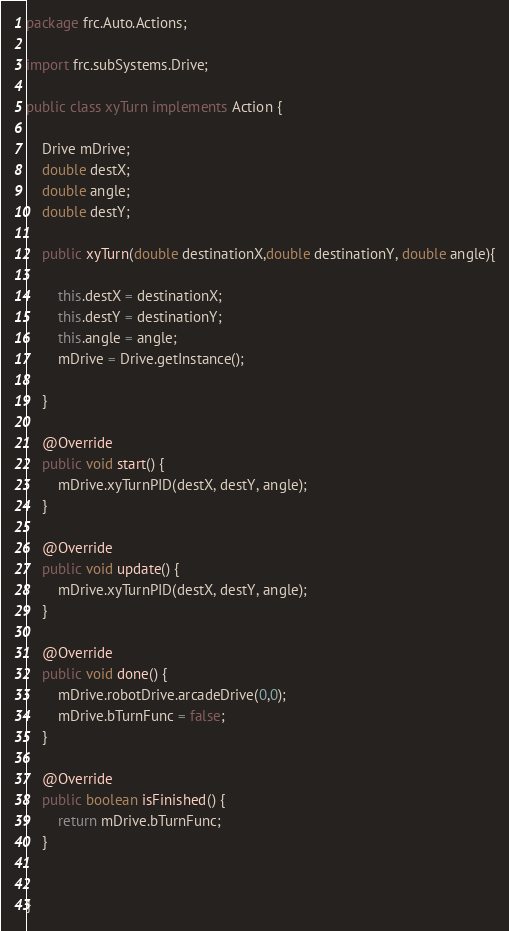<code> <loc_0><loc_0><loc_500><loc_500><_Java_>package frc.Auto.Actions;

import frc.subSystems.Drive;

public class xyTurn implements Action {

    Drive mDrive;
    double destX;
    double angle;
    double destY;

    public xyTurn(double destinationX,double destinationY, double angle){

        this.destX = destinationX;
        this.destY = destinationY;
        this.angle = angle;
        mDrive = Drive.getInstance();

    }

    @Override
    public void start() {
        mDrive.xyTurnPID(destX, destY, angle);
    }

    @Override
    public void update() {
        mDrive.xyTurnPID(destX, destY, angle);
    }

    @Override
    public void done() {
        mDrive.robotDrive.arcadeDrive(0,0);
        mDrive.bTurnFunc = false;
    }

    @Override
    public boolean isFinished() {
        return mDrive.bTurnFunc;
    }


}</code> 